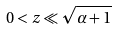<formula> <loc_0><loc_0><loc_500><loc_500>0 < z \ll \sqrt { \alpha + 1 }</formula> 